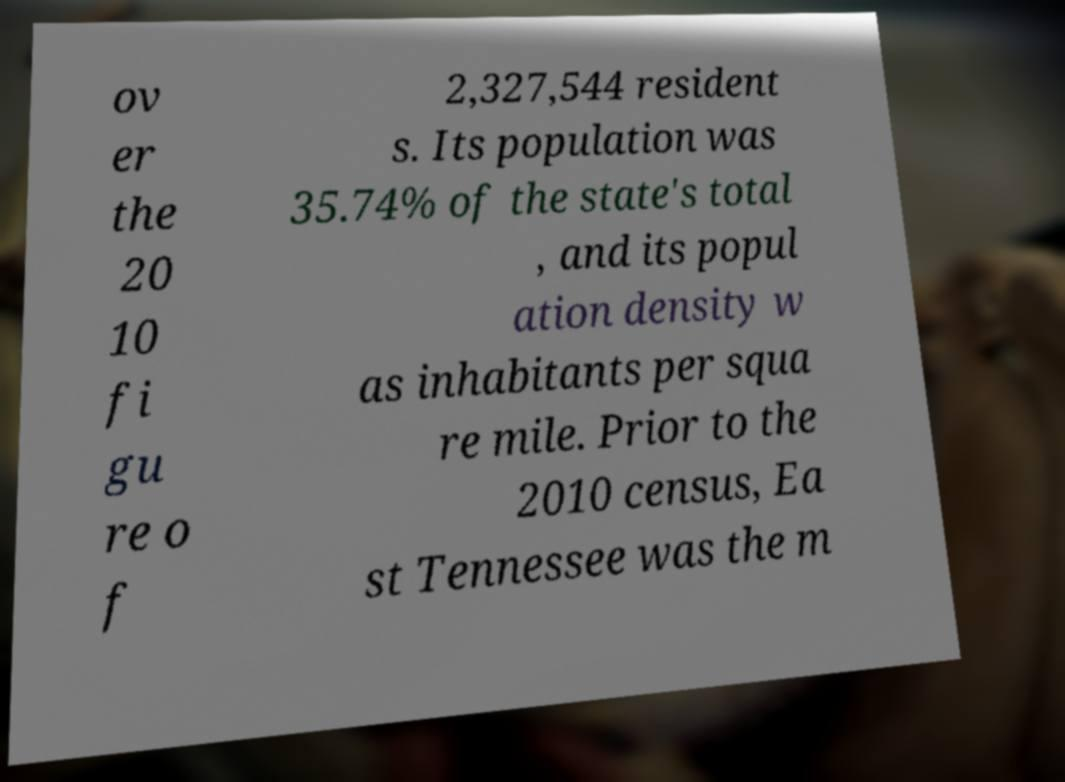There's text embedded in this image that I need extracted. Can you transcribe it verbatim? ov er the 20 10 fi gu re o f 2,327,544 resident s. Its population was 35.74% of the state's total , and its popul ation density w as inhabitants per squa re mile. Prior to the 2010 census, Ea st Tennessee was the m 